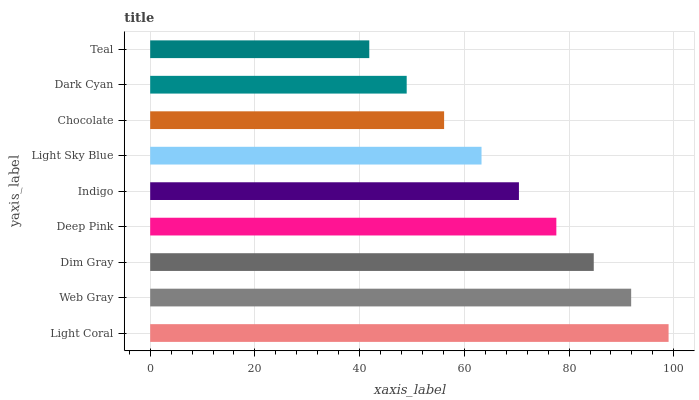Is Teal the minimum?
Answer yes or no. Yes. Is Light Coral the maximum?
Answer yes or no. Yes. Is Web Gray the minimum?
Answer yes or no. No. Is Web Gray the maximum?
Answer yes or no. No. Is Light Coral greater than Web Gray?
Answer yes or no. Yes. Is Web Gray less than Light Coral?
Answer yes or no. Yes. Is Web Gray greater than Light Coral?
Answer yes or no. No. Is Light Coral less than Web Gray?
Answer yes or no. No. Is Indigo the high median?
Answer yes or no. Yes. Is Indigo the low median?
Answer yes or no. Yes. Is Web Gray the high median?
Answer yes or no. No. Is Dim Gray the low median?
Answer yes or no. No. 